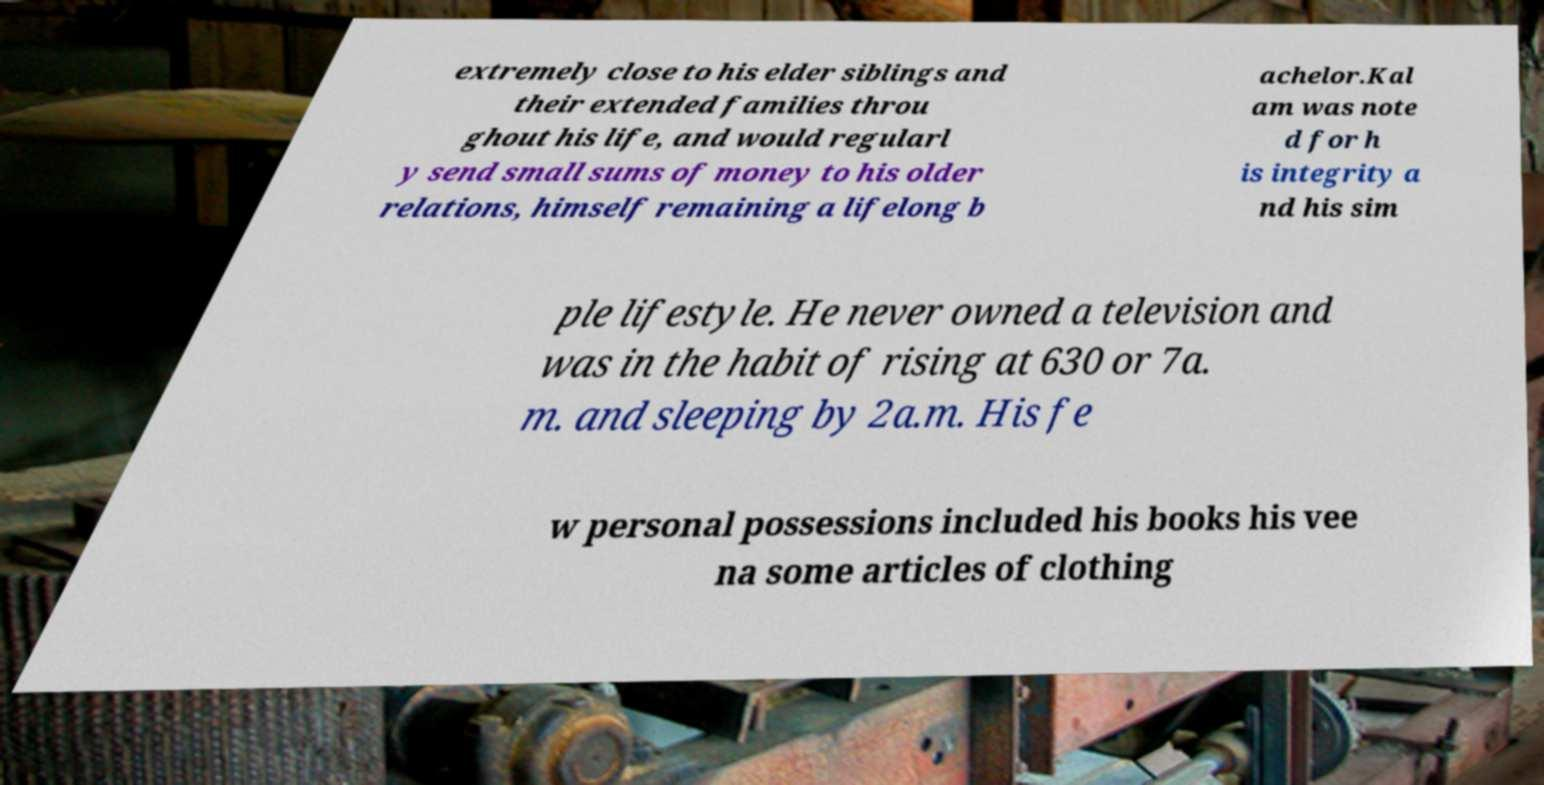Please read and relay the text visible in this image. What does it say? extremely close to his elder siblings and their extended families throu ghout his life, and would regularl y send small sums of money to his older relations, himself remaining a lifelong b achelor.Kal am was note d for h is integrity a nd his sim ple lifestyle. He never owned a television and was in the habit of rising at 630 or 7a. m. and sleeping by 2a.m. His fe w personal possessions included his books his vee na some articles of clothing 